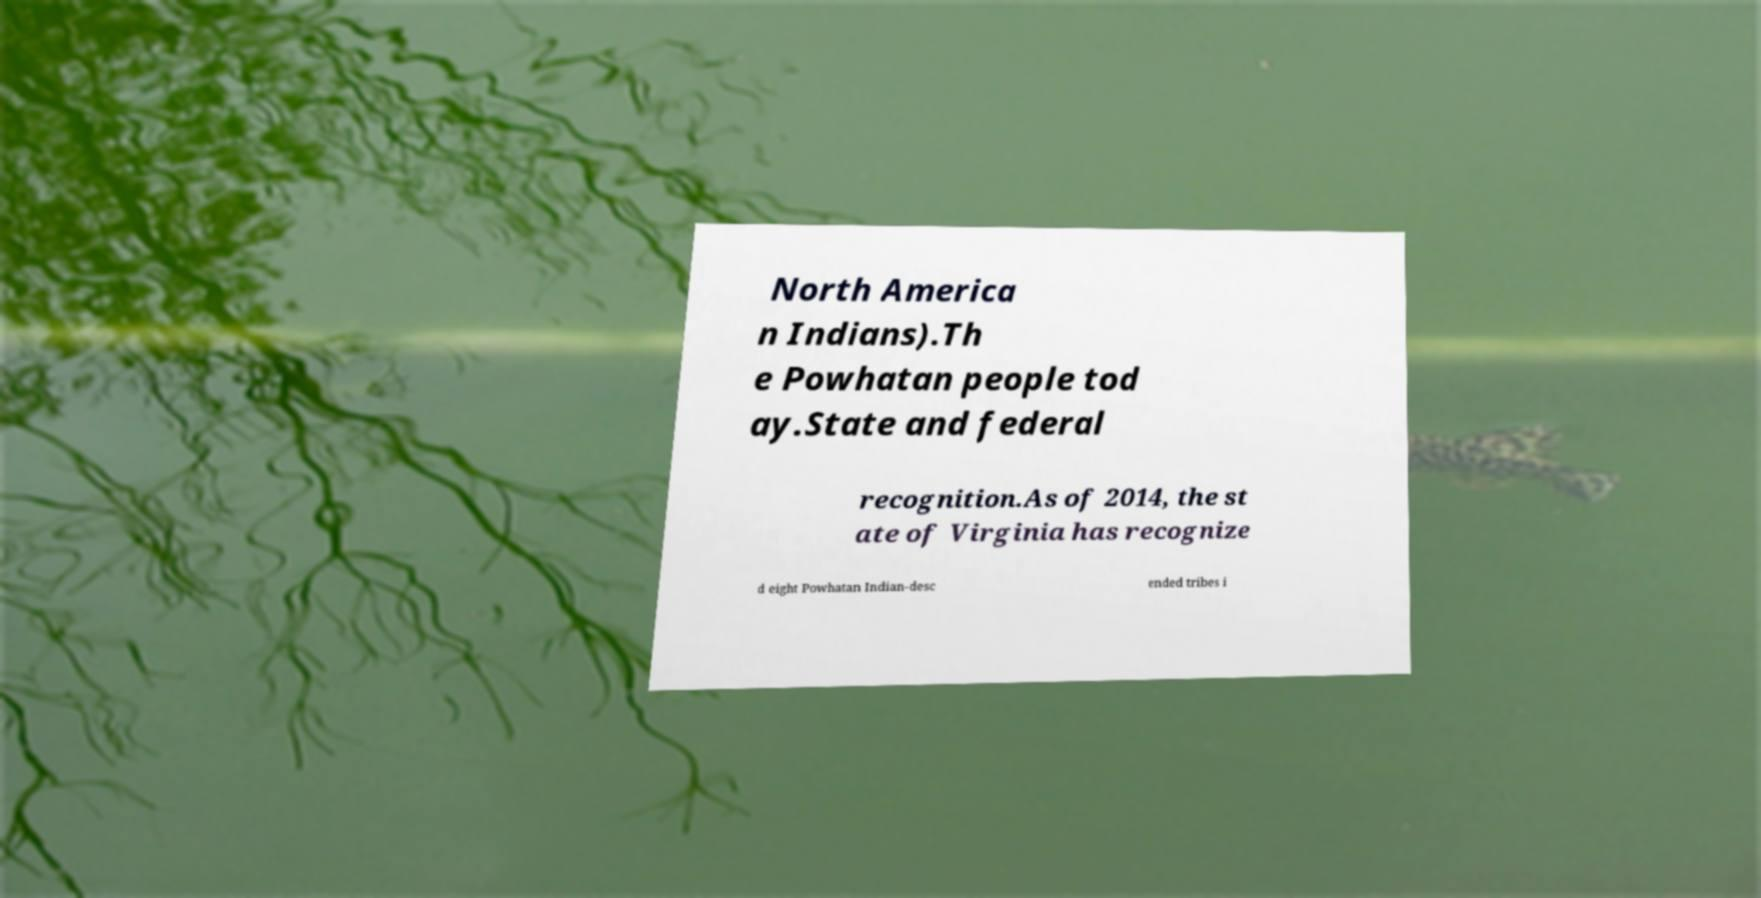Please identify and transcribe the text found in this image. North America n Indians).Th e Powhatan people tod ay.State and federal recognition.As of 2014, the st ate of Virginia has recognize d eight Powhatan Indian-desc ended tribes i 